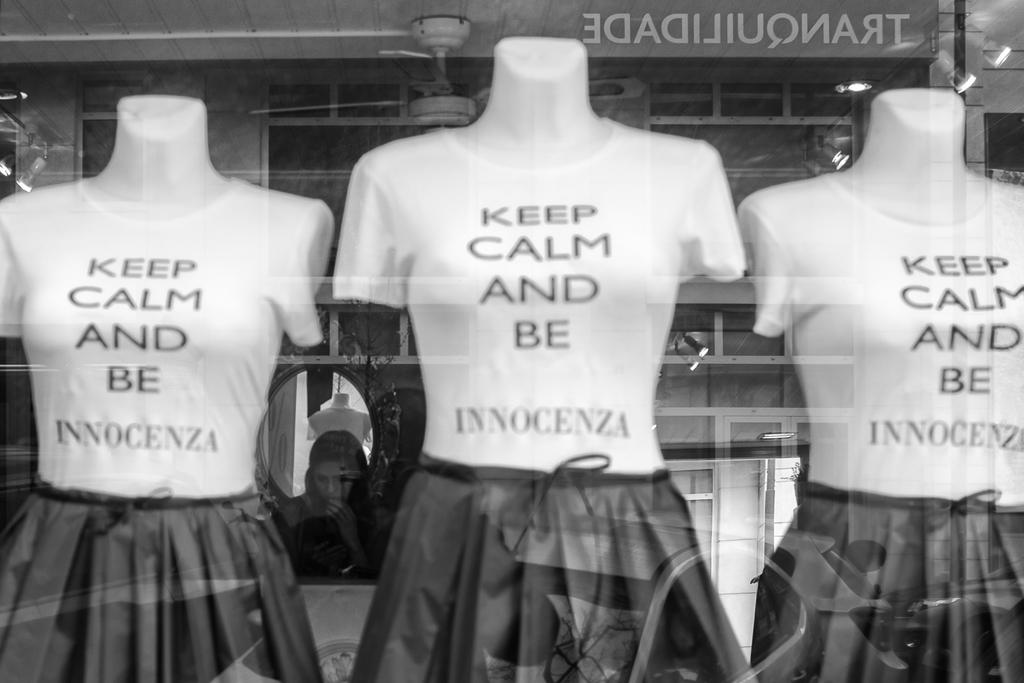How many mannequins are in the image? There are three mannequins in the image. What type of clothing are the mannequins wearing? The mannequins are wearing T-shirts and frocks. Can you describe the background of the image? There is a woman in the background of the image. What can be seen on the roof in the image? There is a fan and lights visible on the roof. What type of creature is crawling on the floor in the image? There is no creature crawling on the floor in the image. How many quarters are visible on the mannequins in the image? There are no quarters present on the mannequins in the image. 